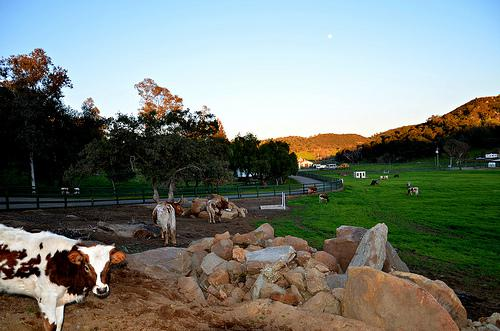Question: how many cows are there?
Choices:
A. Seven.
B. Eleven.
C. Four.
D. Nine.
Answer with the letter. Answer: D Question: when was the picture taken?
Choices:
A. Afternoon.
B. Morning.
C. Evening.
D. Twilight.
Answer with the letter. Answer: B Question: why are the cows in the field?
Choices:
A. To exercise.
B. For fresh air.
C. To graze.
D. To mate.
Answer with the letter. Answer: C 